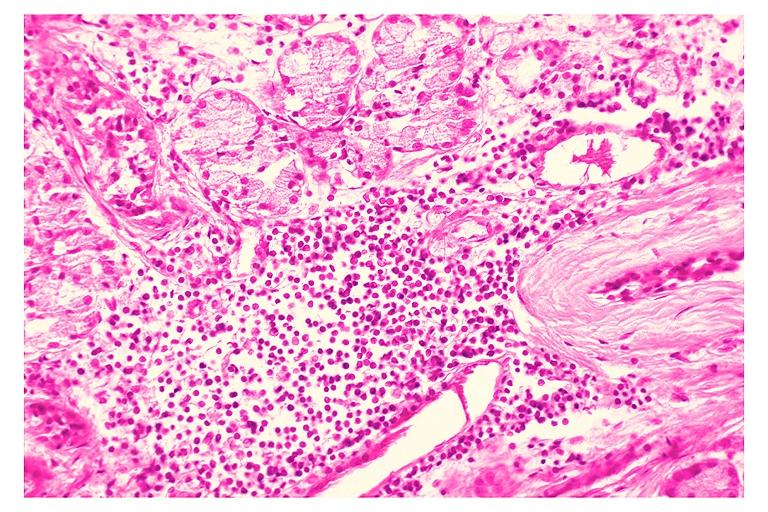s 7182 and 7183 present?
Answer the question using a single word or phrase. No 